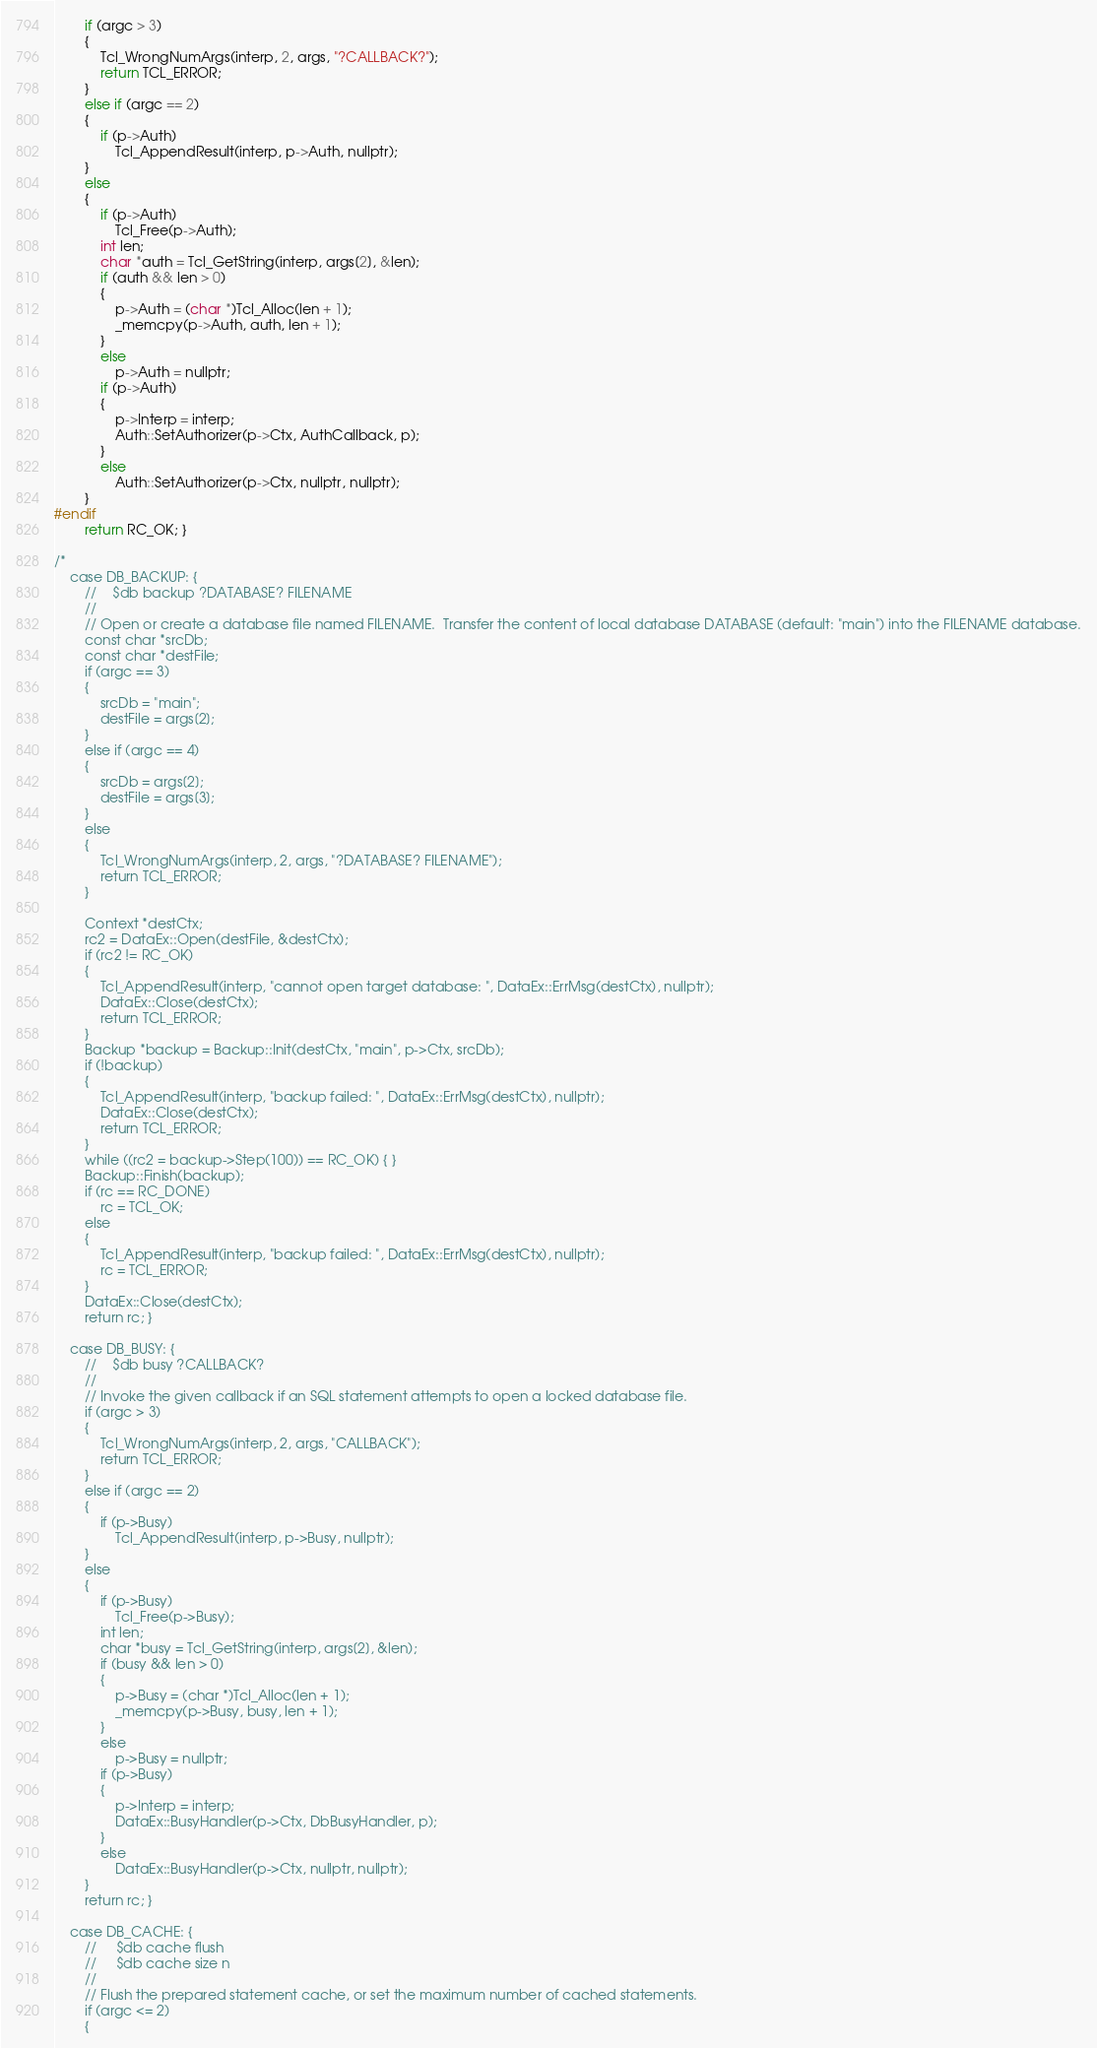<code> <loc_0><loc_0><loc_500><loc_500><_Cuda_>		if (argc > 3)
		{
			Tcl_WrongNumArgs(interp, 2, args, "?CALLBACK?");
			return TCL_ERROR;
		}
		else if (argc == 2)
		{
			if (p->Auth)
				Tcl_AppendResult(interp, p->Auth, nullptr);
		}
		else
		{
			if (p->Auth)
				Tcl_Free(p->Auth);
			int len;
			char *auth = Tcl_GetString(interp, args[2], &len);
			if (auth && len > 0)
			{
				p->Auth = (char *)Tcl_Alloc(len + 1);
				_memcpy(p->Auth, auth, len + 1);
			}
			else
				p->Auth = nullptr;
			if (p->Auth)
			{
				p->Interp = interp;
				Auth::SetAuthorizer(p->Ctx, AuthCallback, p);
			}
			else
				Auth::SetAuthorizer(p->Ctx, nullptr, nullptr);
		}
#endif
		return RC_OK; }

/*
	case DB_BACKUP: {
		//    $db backup ?DATABASE? FILENAME
		//
		// Open or create a database file named FILENAME.  Transfer the content of local database DATABASE (default: "main") into the FILENAME database.
		const char *srcDb;
		const char *destFile;
		if (argc == 3)
		{
			srcDb = "main";
			destFile = args[2];
		}
		else if (argc == 4)
		{
			srcDb = args[2];
			destFile = args[3];
		}
		else
		{
			Tcl_WrongNumArgs(interp, 2, args, "?DATABASE? FILENAME");
			return TCL_ERROR;
		}

		Context *destCtx;
		rc2 = DataEx::Open(destFile, &destCtx);
		if (rc2 != RC_OK)
		{
			Tcl_AppendResult(interp, "cannot open target database: ", DataEx::ErrMsg(destCtx), nullptr);
			DataEx::Close(destCtx);
			return TCL_ERROR;
		}
		Backup *backup = Backup::Init(destCtx, "main", p->Ctx, srcDb);
		if (!backup)
		{
			Tcl_AppendResult(interp, "backup failed: ", DataEx::ErrMsg(destCtx), nullptr);
			DataEx::Close(destCtx);
			return TCL_ERROR;
		}
		while ((rc2 = backup->Step(100)) == RC_OK) { }
		Backup::Finish(backup);
		if (rc == RC_DONE)
			rc = TCL_OK;
		else
		{
			Tcl_AppendResult(interp, "backup failed: ", DataEx::ErrMsg(destCtx), nullptr);
			rc = TCL_ERROR;
		}
		DataEx::Close(destCtx);
		return rc; }

	case DB_BUSY: {
		//    $db busy ?CALLBACK?
		//
		// Invoke the given callback if an SQL statement attempts to open a locked database file.
		if (argc > 3)
		{
			Tcl_WrongNumArgs(interp, 2, args, "CALLBACK");
			return TCL_ERROR;
		}
		else if (argc == 2)
		{
			if (p->Busy)
				Tcl_AppendResult(interp, p->Busy, nullptr);
		}
		else
		{
			if (p->Busy)
				Tcl_Free(p->Busy);
			int len;
			char *busy = Tcl_GetString(interp, args[2], &len);
			if (busy && len > 0)
			{
				p->Busy = (char *)Tcl_Alloc(len + 1);
				_memcpy(p->Busy, busy, len + 1);
			}
			else
				p->Busy = nullptr;
			if (p->Busy)
			{
				p->Interp = interp;
				DataEx::BusyHandler(p->Ctx, DbBusyHandler, p);
			}
			else
				DataEx::BusyHandler(p->Ctx, nullptr, nullptr);
		}
		return rc; }

	case DB_CACHE: {
		//     $db cache flush
		//     $db cache size n
		//
		// Flush the prepared statement cache, or set the maximum number of cached statements.
		if (argc <= 2)
		{</code> 